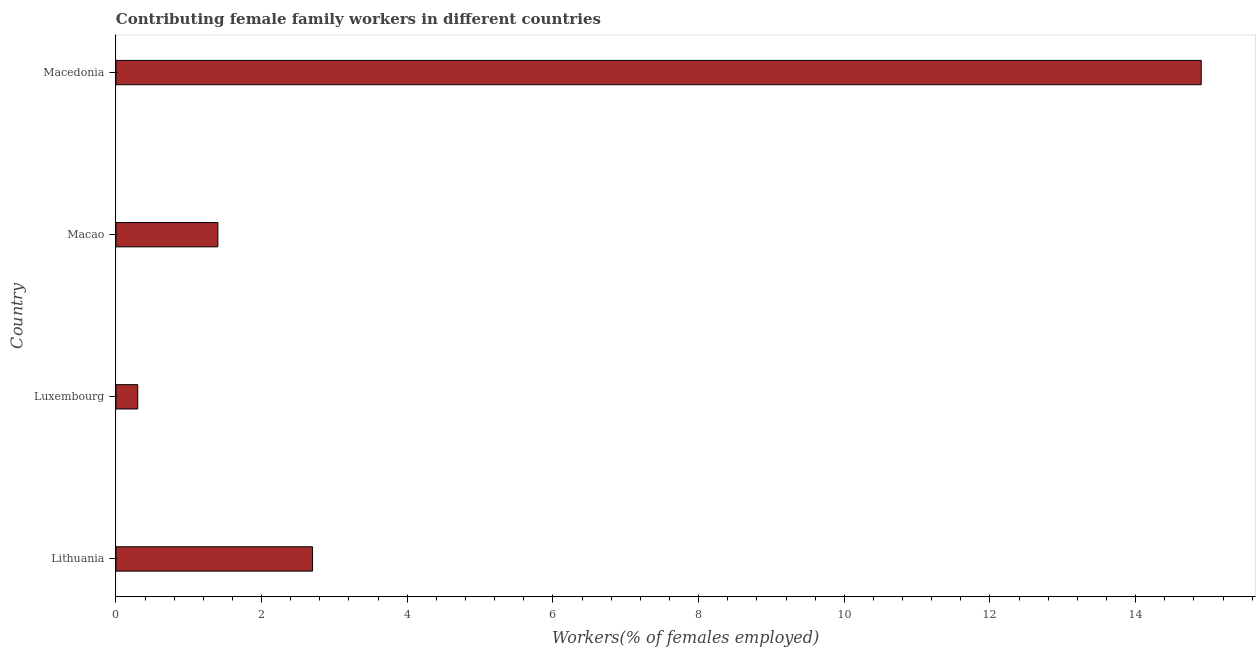Does the graph contain any zero values?
Ensure brevity in your answer.  No. What is the title of the graph?
Ensure brevity in your answer.  Contributing female family workers in different countries. What is the label or title of the X-axis?
Your answer should be compact. Workers(% of females employed). What is the contributing female family workers in Lithuania?
Provide a short and direct response. 2.7. Across all countries, what is the maximum contributing female family workers?
Give a very brief answer. 14.9. Across all countries, what is the minimum contributing female family workers?
Your answer should be compact. 0.3. In which country was the contributing female family workers maximum?
Your response must be concise. Macedonia. In which country was the contributing female family workers minimum?
Keep it short and to the point. Luxembourg. What is the sum of the contributing female family workers?
Offer a terse response. 19.3. What is the difference between the contributing female family workers in Luxembourg and Macedonia?
Give a very brief answer. -14.6. What is the average contributing female family workers per country?
Ensure brevity in your answer.  4.83. What is the median contributing female family workers?
Your answer should be very brief. 2.05. In how many countries, is the contributing female family workers greater than 5.6 %?
Your response must be concise. 1. What is the ratio of the contributing female family workers in Lithuania to that in Macao?
Offer a very short reply. 1.93. What is the difference between the highest and the second highest contributing female family workers?
Your response must be concise. 12.2. Is the sum of the contributing female family workers in Luxembourg and Macao greater than the maximum contributing female family workers across all countries?
Provide a short and direct response. No. How many countries are there in the graph?
Make the answer very short. 4. What is the difference between two consecutive major ticks on the X-axis?
Keep it short and to the point. 2. Are the values on the major ticks of X-axis written in scientific E-notation?
Your answer should be compact. No. What is the Workers(% of females employed) of Lithuania?
Give a very brief answer. 2.7. What is the Workers(% of females employed) of Luxembourg?
Offer a very short reply. 0.3. What is the Workers(% of females employed) in Macao?
Give a very brief answer. 1.4. What is the Workers(% of females employed) in Macedonia?
Ensure brevity in your answer.  14.9. What is the difference between the Workers(% of females employed) in Lithuania and Macedonia?
Provide a succinct answer. -12.2. What is the difference between the Workers(% of females employed) in Luxembourg and Macedonia?
Your answer should be very brief. -14.6. What is the ratio of the Workers(% of females employed) in Lithuania to that in Macao?
Offer a very short reply. 1.93. What is the ratio of the Workers(% of females employed) in Lithuania to that in Macedonia?
Make the answer very short. 0.18. What is the ratio of the Workers(% of females employed) in Luxembourg to that in Macao?
Give a very brief answer. 0.21. What is the ratio of the Workers(% of females employed) in Luxembourg to that in Macedonia?
Your response must be concise. 0.02. What is the ratio of the Workers(% of females employed) in Macao to that in Macedonia?
Make the answer very short. 0.09. 